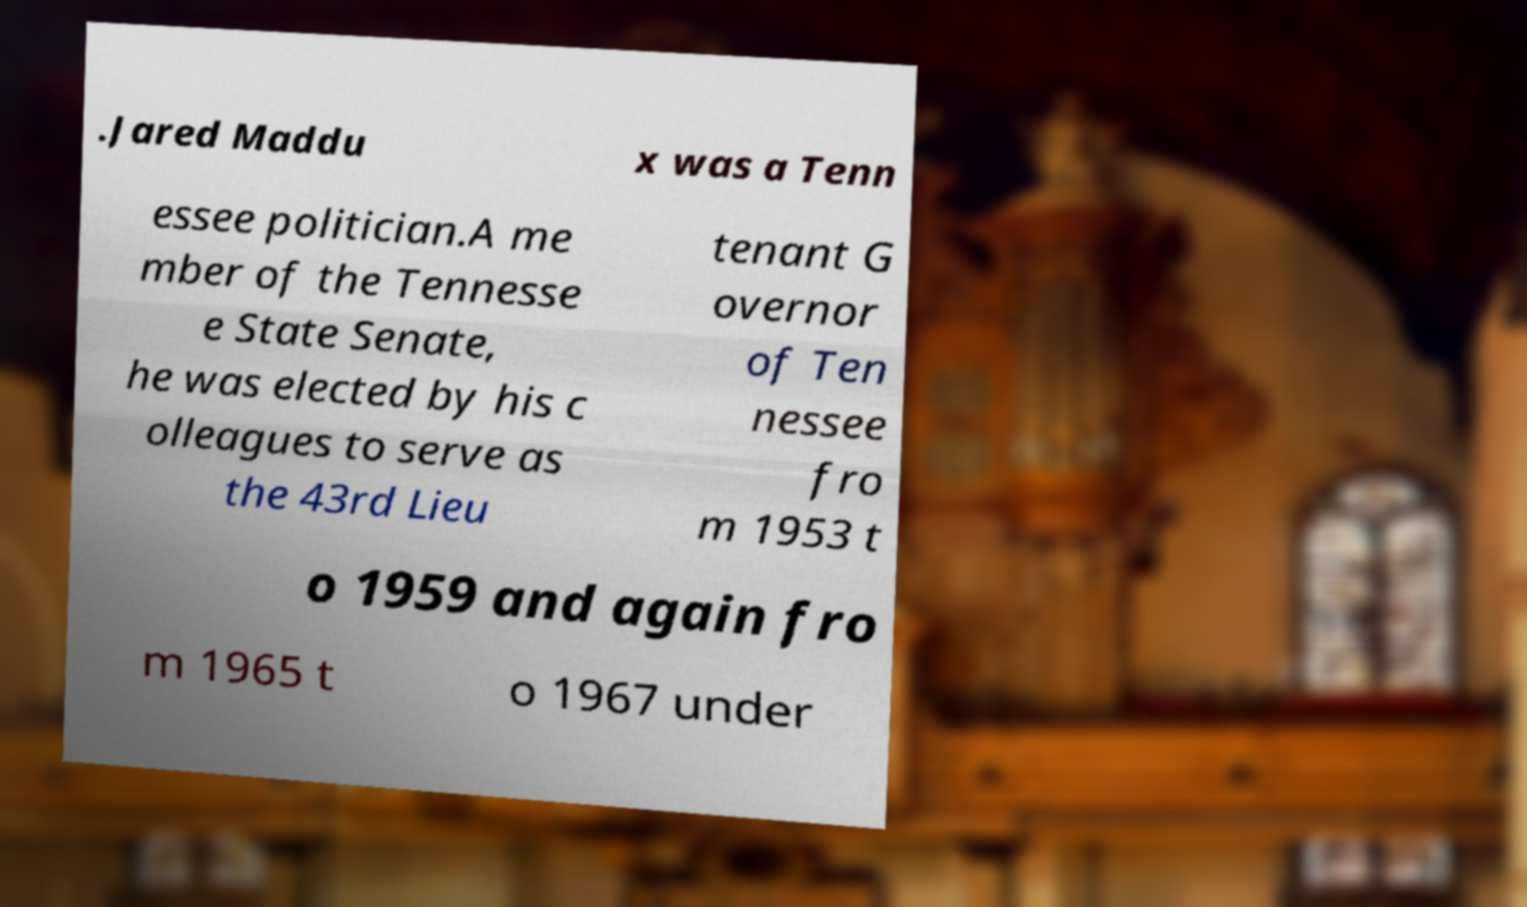What messages or text are displayed in this image? I need them in a readable, typed format. .Jared Maddu x was a Tenn essee politician.A me mber of the Tennesse e State Senate, he was elected by his c olleagues to serve as the 43rd Lieu tenant G overnor of Ten nessee fro m 1953 t o 1959 and again fro m 1965 t o 1967 under 